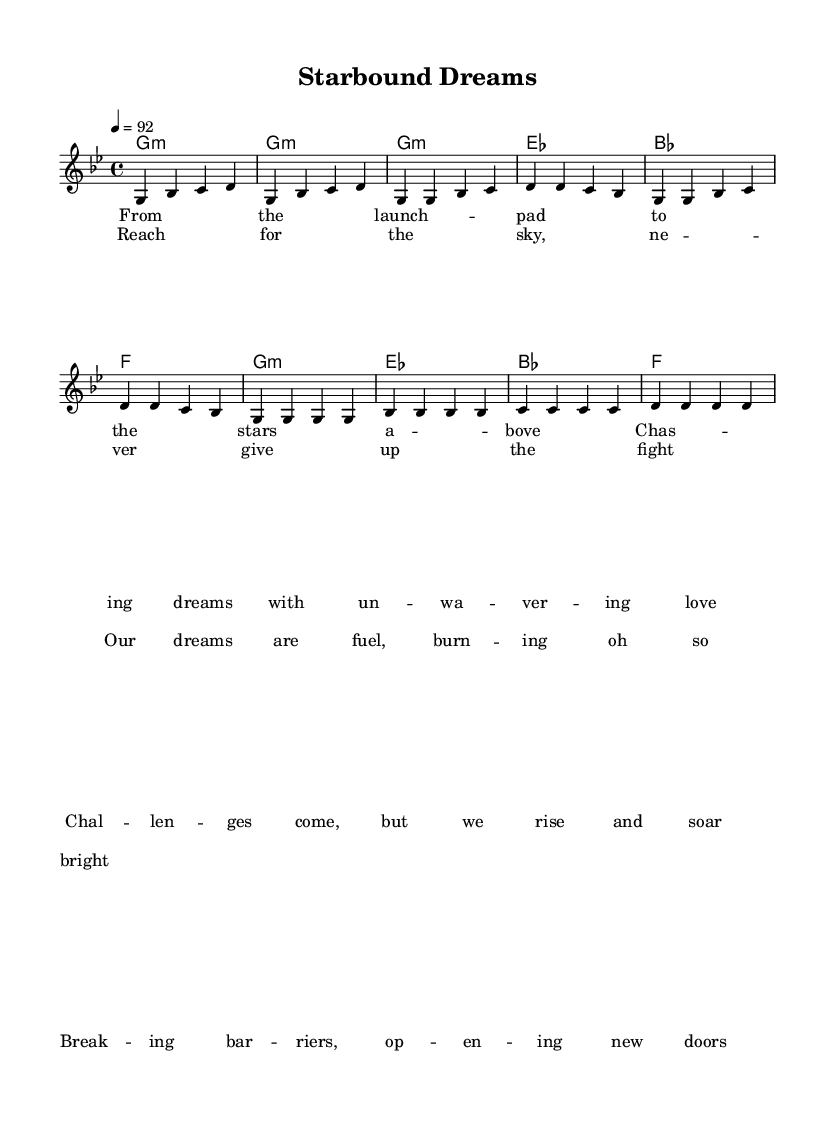What is the key signature of this music? The key signature is G minor, which is indicated by the two flats present in the score.
Answer: G minor What is the time signature of this piece? The time signature is 4/4, which is noted at the beginning of the score, indicating four beats per measure.
Answer: 4/4 What is the tempo marking of the music? The tempo marking is 92 beats per minute, as specified at the start of the piece with "4 = 92."
Answer: 92 How many measures are there in the chorus section? By counting the measures indicated in the chorus lyrics and melody, there are four measures in the chorus section.
Answer: 4 What is the main theme expressed in the lyrics? The lyrics convey a message of motivation and resilience in the face of challenges, emphasizing the pursuit of dreams.
Answer: Motivation Which chord begins the piece? The piece starts with the G minor chord, as shown in the harmonies indicated at the beginning of the score.
Answer: G minor 